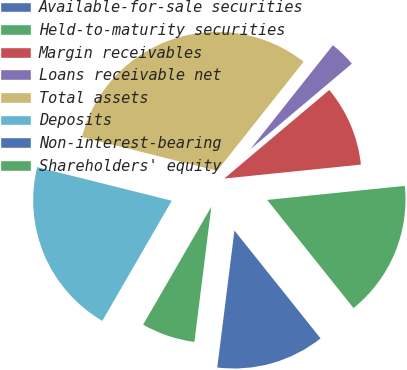Convert chart. <chart><loc_0><loc_0><loc_500><loc_500><pie_chart><fcel>Available-for-sale securities<fcel>Held-to-maturity securities<fcel>Margin receivables<fcel>Loans receivable net<fcel>Total assets<fcel>Deposits<fcel>Non-interest-bearing<fcel>Shareholders' equity<nl><fcel>12.71%<fcel>15.89%<fcel>9.53%<fcel>3.18%<fcel>31.78%<fcel>20.55%<fcel>0.0%<fcel>6.36%<nl></chart> 